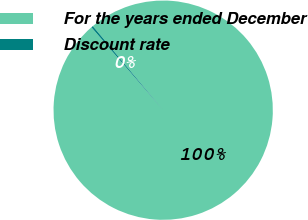Convert chart. <chart><loc_0><loc_0><loc_500><loc_500><pie_chart><fcel>For the years ended December<fcel>Discount rate<nl><fcel>99.73%<fcel>0.27%<nl></chart> 